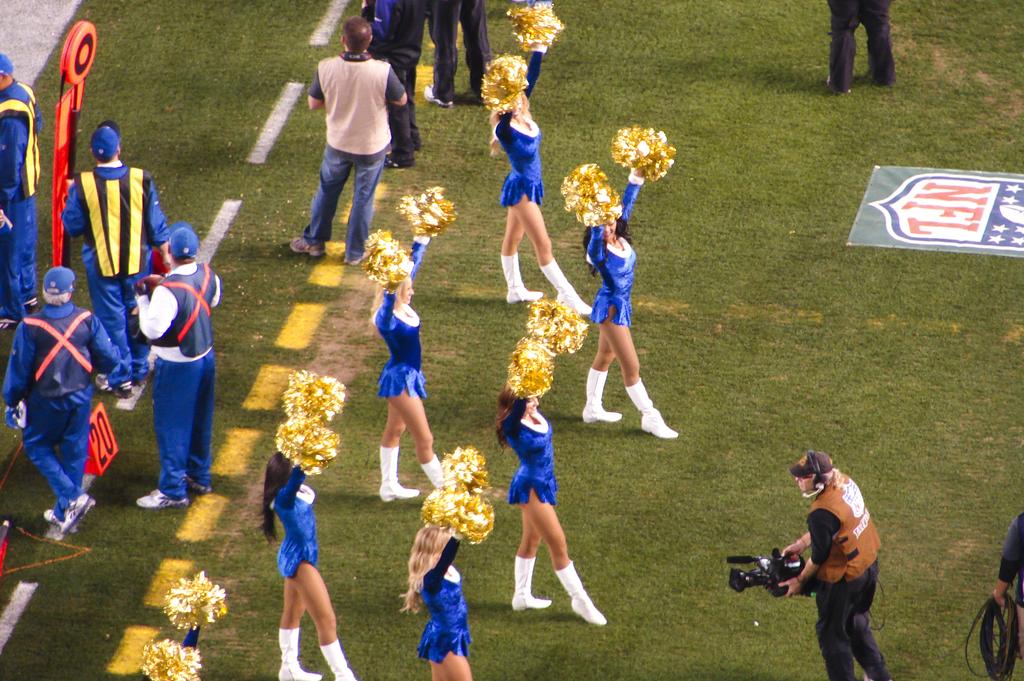What kind of field are the cheerleaders standing on?
Your response must be concise. Nfl. What number is on the orange cone?
Give a very brief answer. 20. 